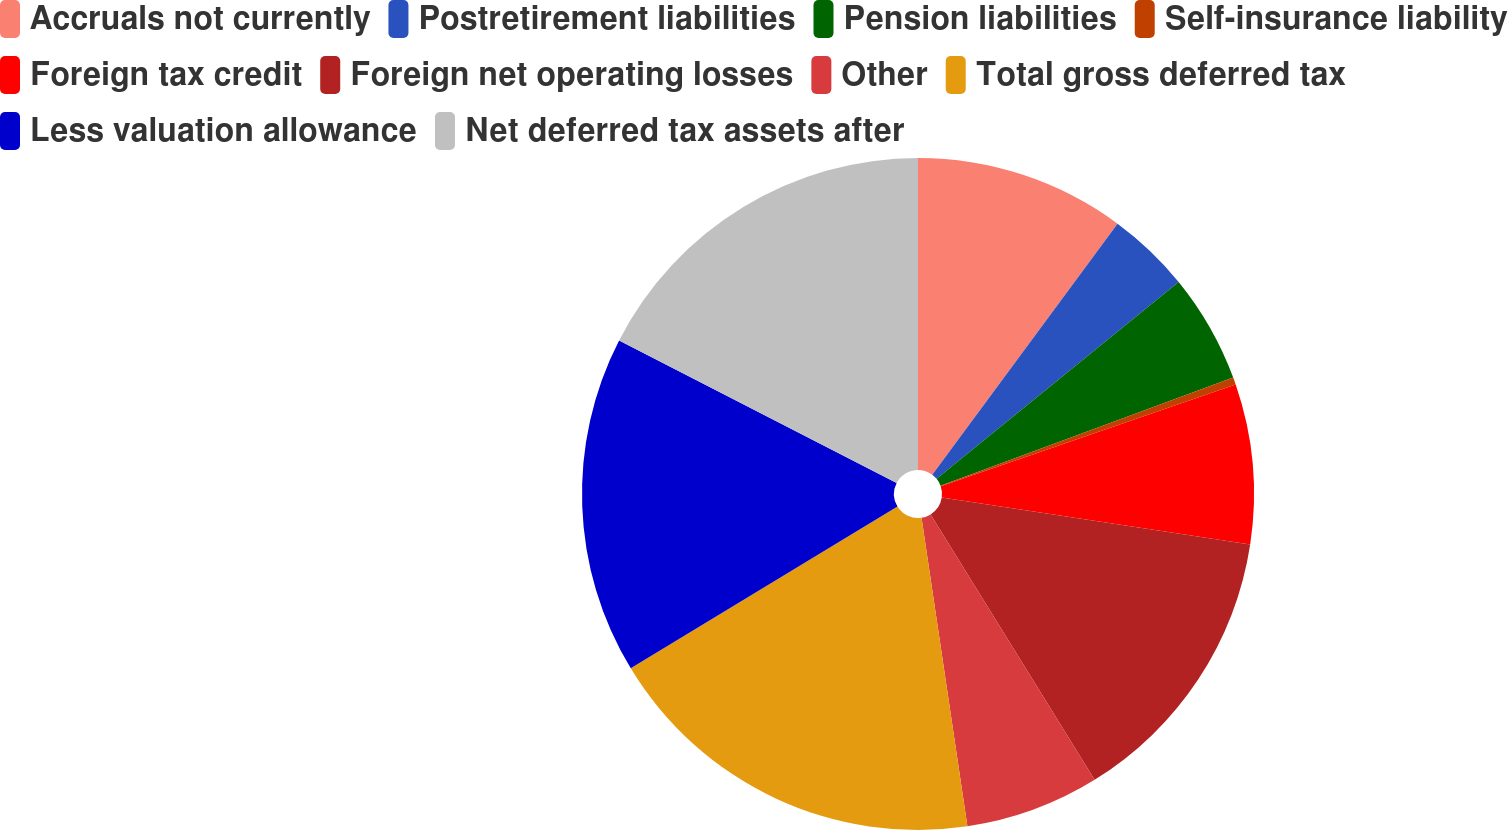Convert chart to OTSL. <chart><loc_0><loc_0><loc_500><loc_500><pie_chart><fcel>Accruals not currently<fcel>Postretirement liabilities<fcel>Pension liabilities<fcel>Self-insurance liability<fcel>Foreign tax credit<fcel>Foreign net operating losses<fcel>Other<fcel>Total gross deferred tax<fcel>Less valuation allowance<fcel>Net deferred tax assets after<nl><fcel>10.12%<fcel>4.01%<fcel>5.24%<fcel>0.35%<fcel>7.68%<fcel>13.79%<fcel>6.46%<fcel>18.67%<fcel>16.23%<fcel>17.45%<nl></chart> 